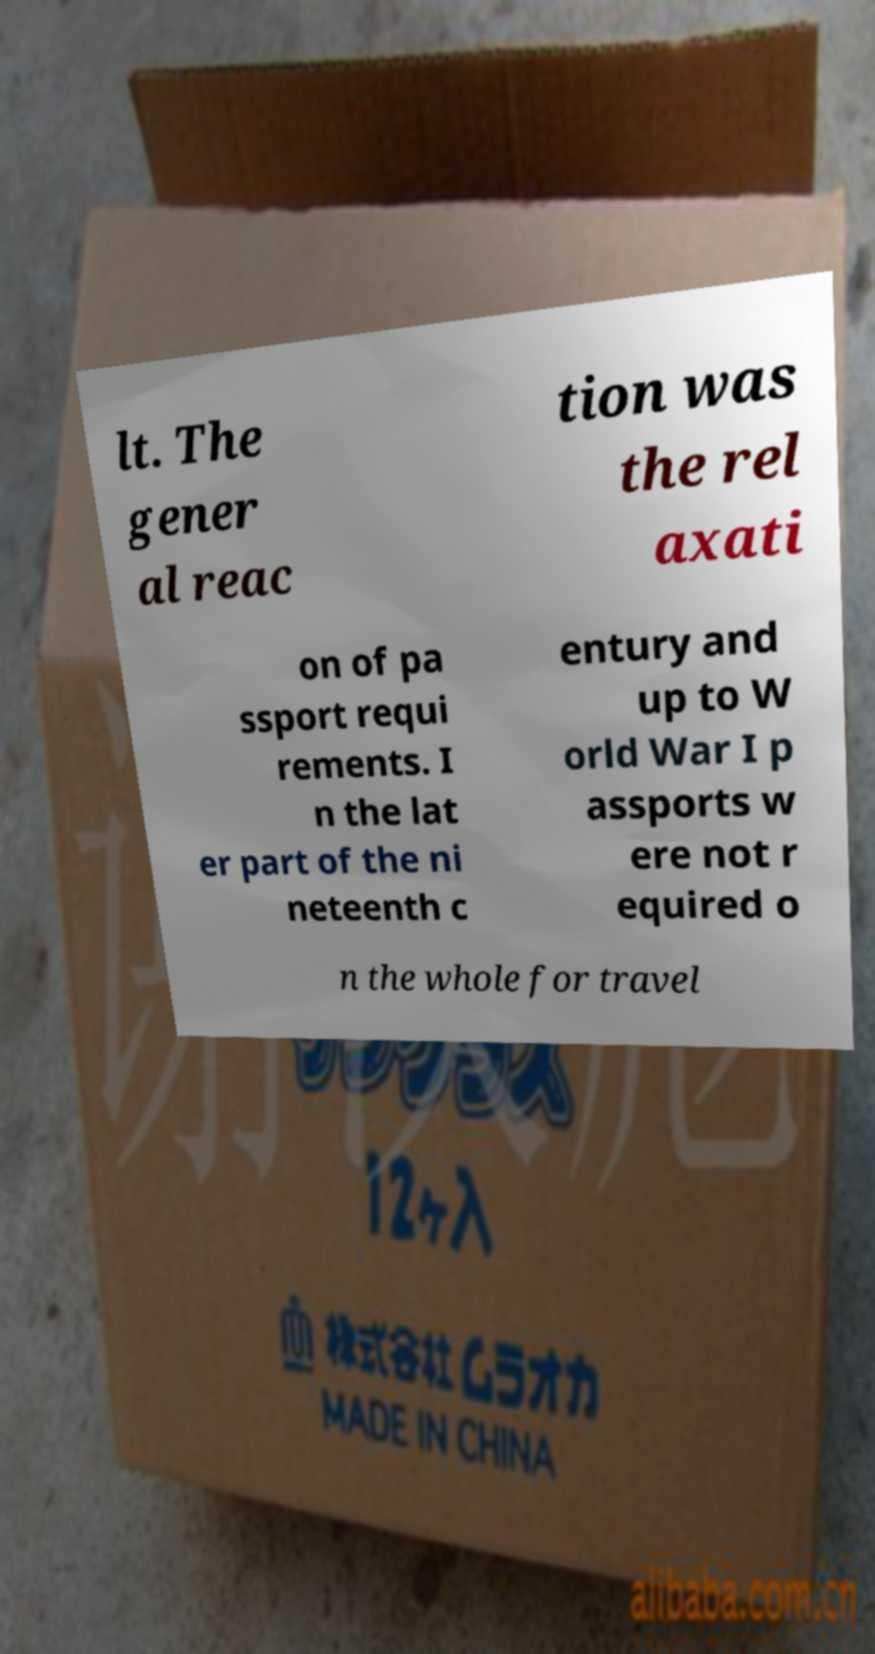Please read and relay the text visible in this image. What does it say? lt. The gener al reac tion was the rel axati on of pa ssport requi rements. I n the lat er part of the ni neteenth c entury and up to W orld War I p assports w ere not r equired o n the whole for travel 